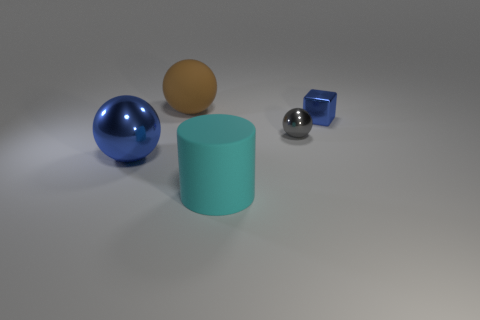The gray object that is the same size as the blue shiny cube is what shape?
Give a very brief answer. Sphere. How many other objects are there of the same color as the large cylinder?
Provide a succinct answer. 0. What is the material of the brown ball?
Ensure brevity in your answer.  Rubber. How many other things are made of the same material as the tiny blue block?
Your answer should be compact. 2. What is the size of the metal object that is right of the big matte cylinder and on the left side of the small blue object?
Give a very brief answer. Small. What shape is the large thing right of the large ball behind the big blue ball?
Keep it short and to the point. Cylinder. Are there any other things that are the same shape as the big brown matte object?
Keep it short and to the point. Yes. Are there the same number of large cylinders to the left of the cylinder and large green matte objects?
Offer a very short reply. Yes. Does the small shiny block have the same color as the ball that is to the right of the cylinder?
Your answer should be compact. No. There is a shiny object that is in front of the small metal block and on the right side of the brown object; what is its color?
Your answer should be compact. Gray. 